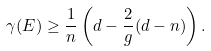<formula> <loc_0><loc_0><loc_500><loc_500>\gamma ( E ) \geq \frac { 1 } { n } \left ( d - \frac { 2 } { g } ( d - n ) \right ) .</formula> 